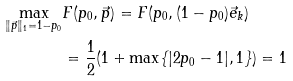Convert formula to latex. <formula><loc_0><loc_0><loc_500><loc_500>\max _ { \| \vec { p } \| _ { 1 } = 1 - p _ { 0 } } & F ( p _ { 0 } , \vec { p } ) = F ( p _ { 0 } , ( 1 - p _ { 0 } ) \vec { e } _ { k } ) \\ & = \frac { 1 } { 2 } ( 1 + \max \{ | 2 p _ { 0 } - 1 | , 1 \} ) = 1</formula> 